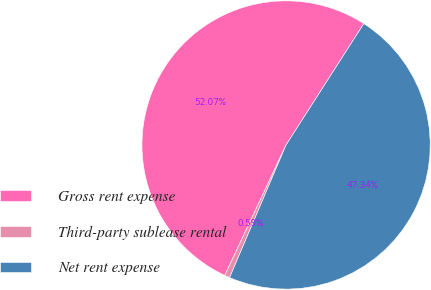Convert chart. <chart><loc_0><loc_0><loc_500><loc_500><pie_chart><fcel>Gross rent expense<fcel>Third-party sublease rental<fcel>Net rent expense<nl><fcel>52.07%<fcel>0.59%<fcel>47.34%<nl></chart> 